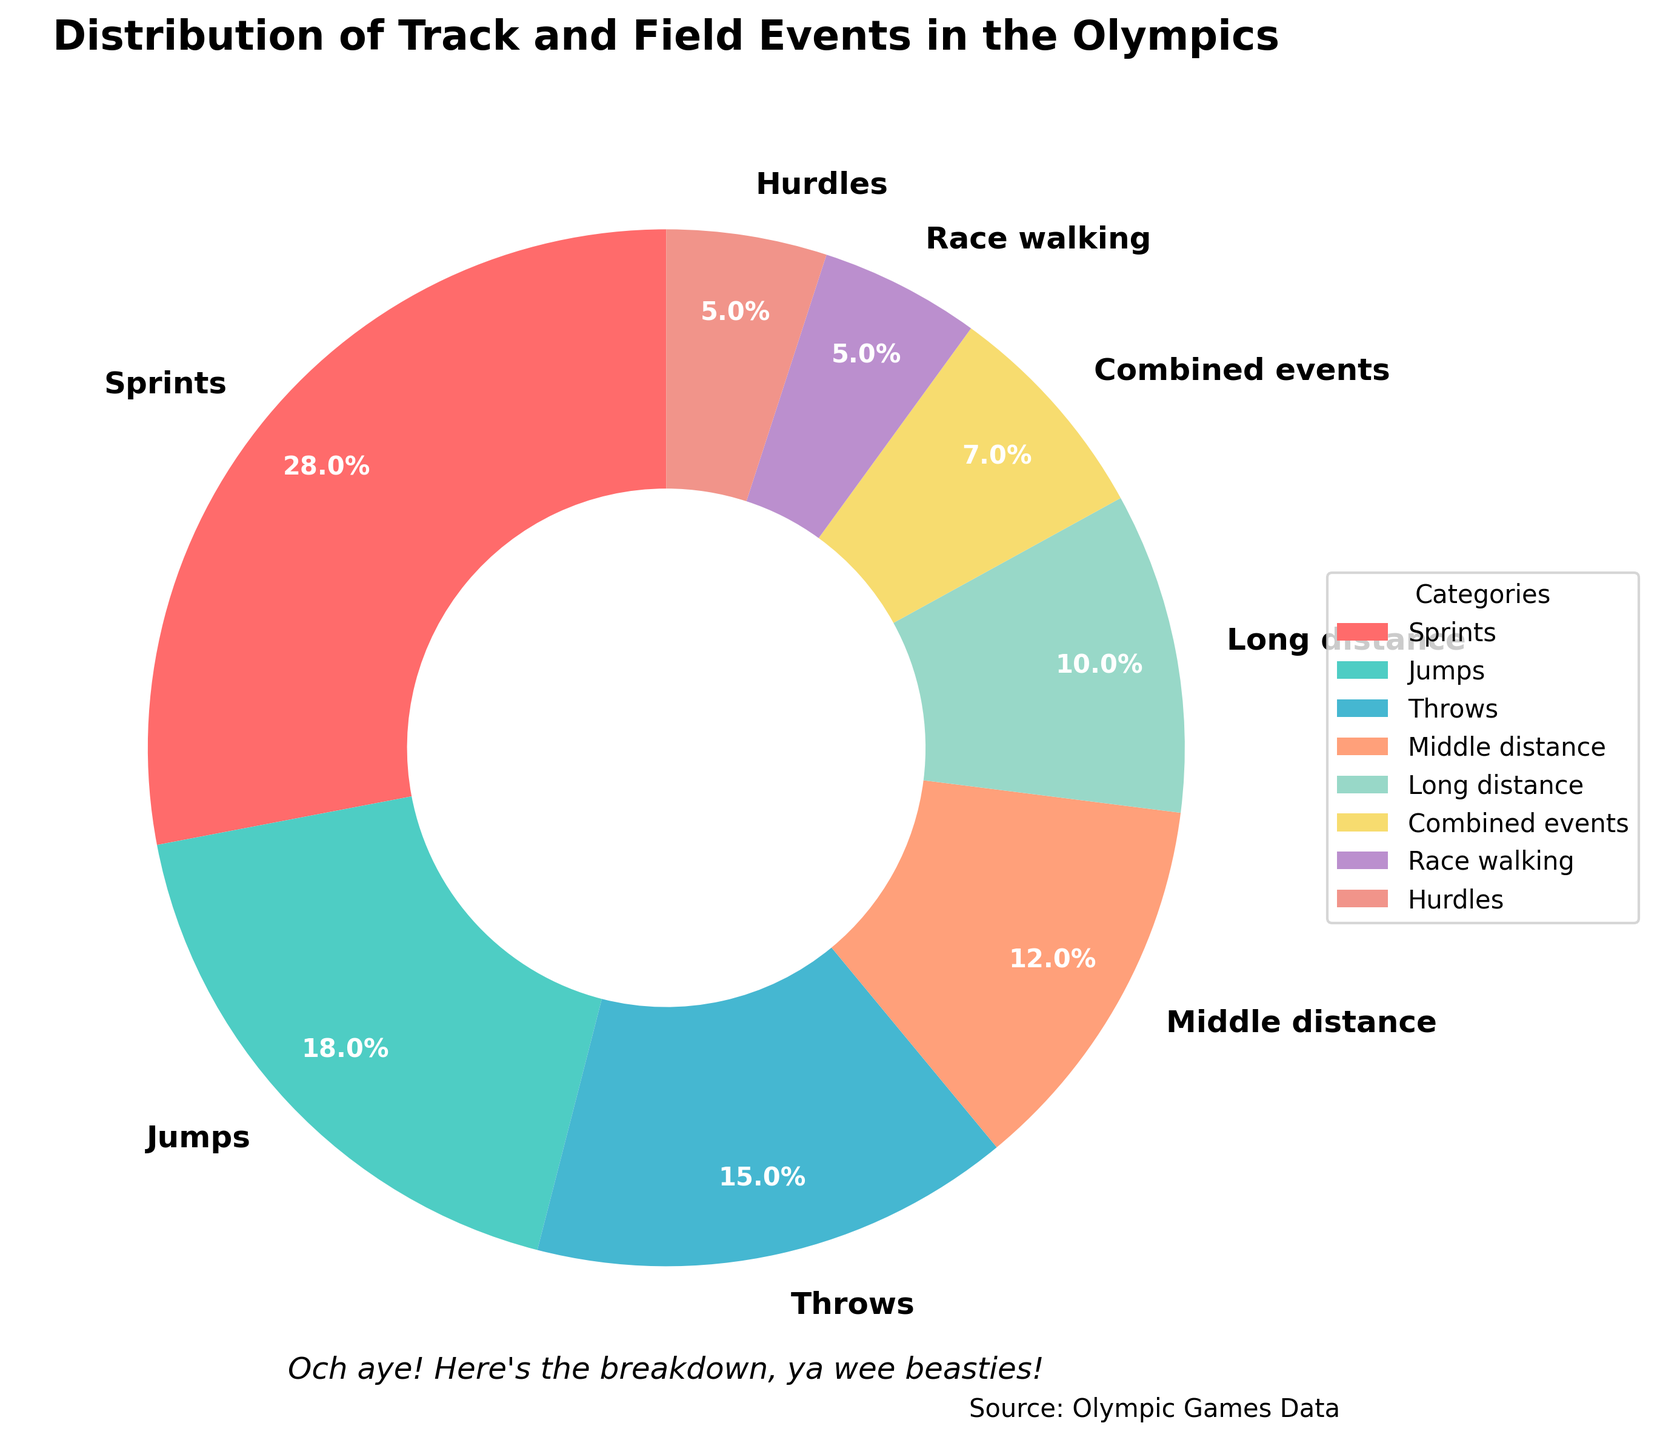What's the largest category in terms of percentage? The largest category is represented by the largest section of the pie chart, which is labeled "Sprints" with 28%.
Answer: Sprints Which categories have the same percentage, and what is that percentage? The categories that have the same percentage are represented by equally sized sections of the pie chart. Both "Race walking" and "Hurdles" have 5%.
Answer: Race walking and Hurdles, 5% How much more is the percentage of Sprints compared to Throws? Find the percentage for each category: Sprints (28%) and Throws (15%), then subtract Throws from Sprints (28% - 15%).
Answer: 13% Which category has the smallest representation in the pie chart? The category with the smallest representation will have the smallest segment labeled, which is "Race walking" with 5%.
Answer: Race walking What is the combined percentage of Throws and Jumps? Combine the percentages for Throws (15%) and Jumps (18%) by adding them together (15% + 18%).
Answer: 33% How many categories have a percentage greater than 10%? Identify and count all the categories with percentages above 10%: Sprints (28%), Jumps (18%), Throws (15%), and Middle distance (12%).
Answer: 4 Identify the category in the light blue section of the pie chart and its percentage. The light blue section of the pie chart corresponds to the "Middle distance" category, which is labeled as 12%.
Answer: Middle distance, 12% What is the combined percentage of all categories except the one with the smallest representation? Exclude the smallest category "Race walking" (5%), then add the percentages of the remaining categories: (28 + 18 + 15 + 12 + 10 + 7 + 5). Alternatively, subtract 5% from 100% (100% - 5%).
Answer: 95% Compare the combined percentage of Sprints and Jumps to that of Throws and Middle distance. Which is higher and by how much? Calculate the combined percentages: Sprints and Jumps is (28% + 18% = 46%), Throws and Middle distance is (15% + 12% = 27%). Subtract Throws and Middle distance's total from Sprints and Jumps' total (46% - 27%).
Answer: Sprints and Jumps is higher by 19% Which category represented by the orange section, and how does its percentage compare to that of Long distance? The orange section corresponds to "Middle distance" with 12%. To compare, "Long distance" has 10%, so "Middle distance" has 2% more (12% - 10%).
Answer: Middle distance, 2% more 